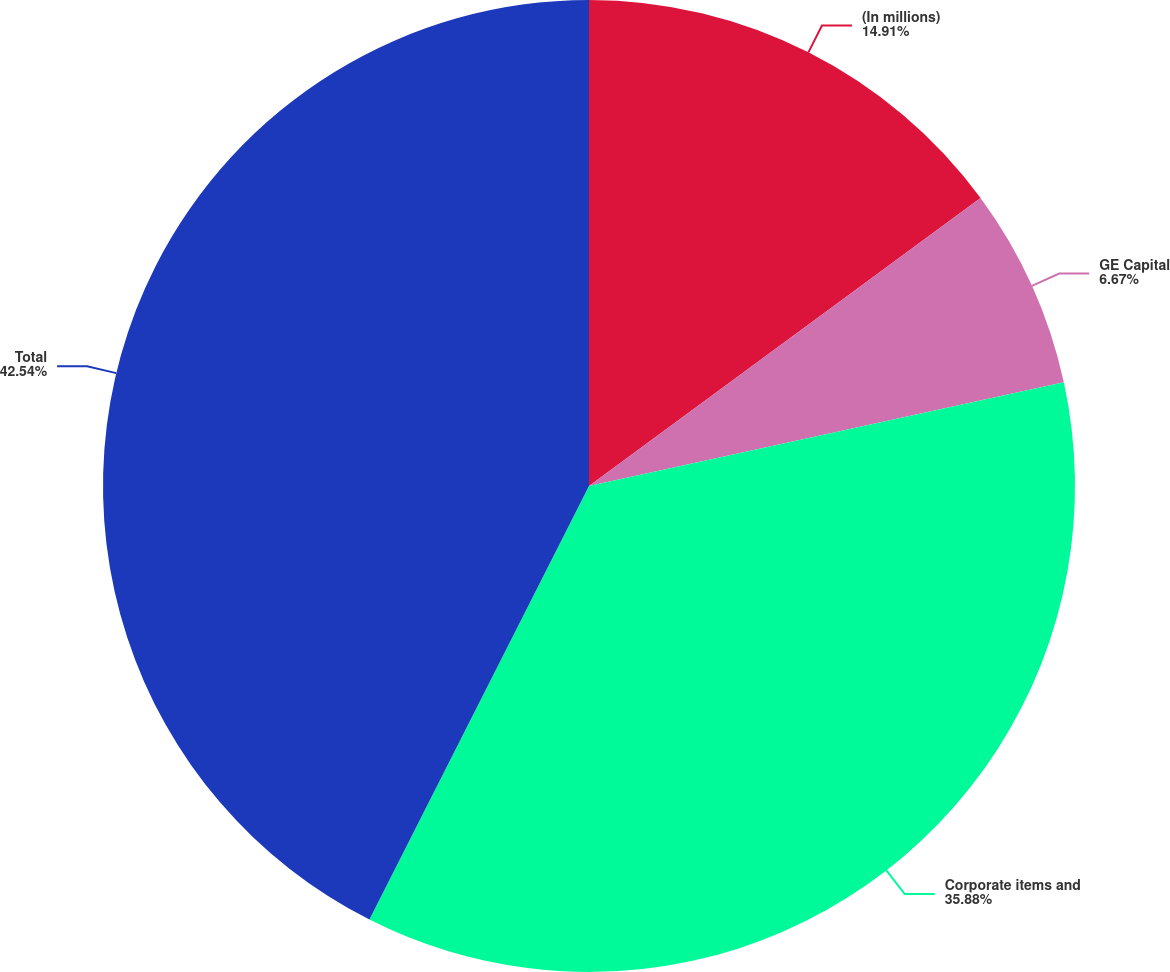Convert chart. <chart><loc_0><loc_0><loc_500><loc_500><pie_chart><fcel>(In millions)<fcel>GE Capital<fcel>Corporate items and<fcel>Total<nl><fcel>14.91%<fcel>6.67%<fcel>35.88%<fcel>42.54%<nl></chart> 